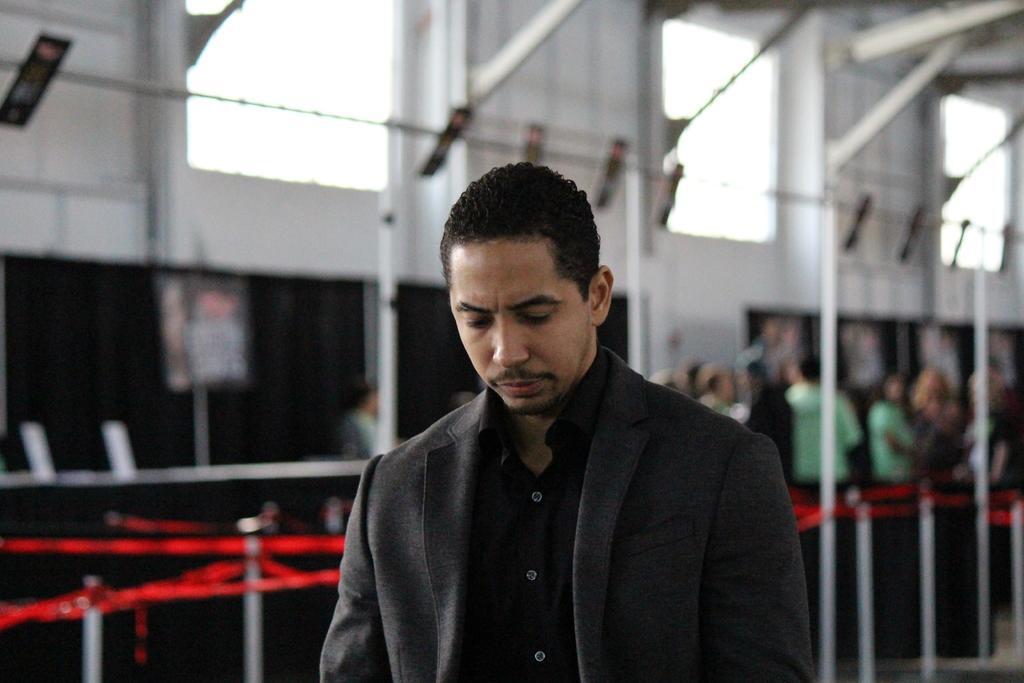Describe this image in one or two sentences. The man is highlighted in this picture. He is looking downwards. He wore black jacket, black shirt. Far there is a queue of people standing. There are red ribbons and poles. The one pole is connected with one pole with help of ribbons. There is window on the top. 